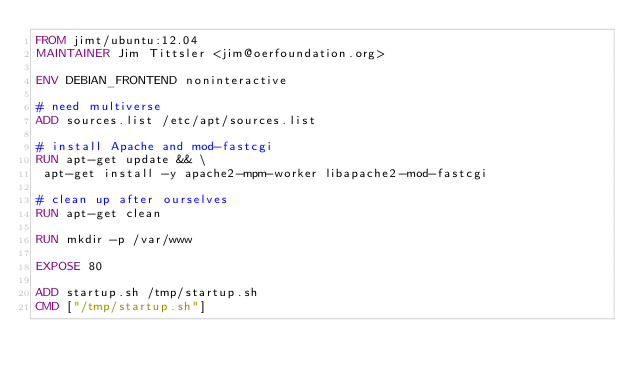<code> <loc_0><loc_0><loc_500><loc_500><_Dockerfile_>FROM jimt/ubuntu:12.04
MAINTAINER Jim Tittsler <jim@oerfoundation.org>

ENV DEBIAN_FRONTEND noninteractive

# need multiverse
ADD sources.list /etc/apt/sources.list

# install Apache and mod-fastcgi
RUN apt-get update && \
 apt-get install -y apache2-mpm-worker libapache2-mod-fastcgi

# clean up after ourselves
RUN apt-get clean

RUN mkdir -p /var/www

EXPOSE 80

ADD startup.sh /tmp/startup.sh
CMD ["/tmp/startup.sh"]

</code> 